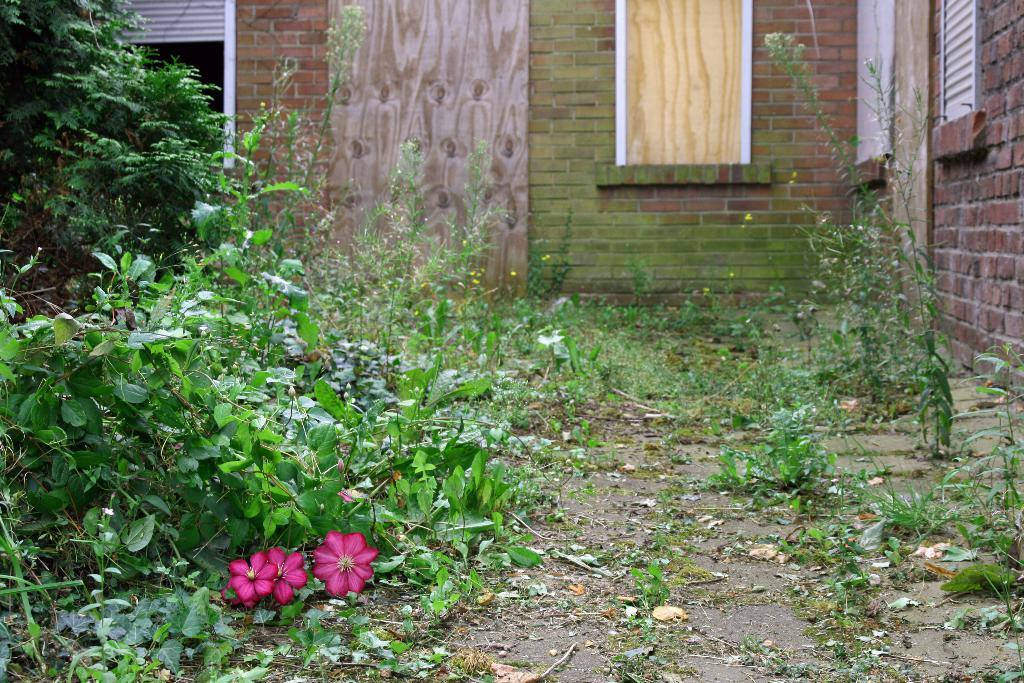What type of plants are present in the image? There are plants with flowers in the image. What color are the flowers on the plants? The flowers are pink in color. What can be seen in the background of the image? There is a brick wall and windows visible in the background of the image. Are there any toys visible in the image? No, there are no toys present in the image. Can you see any fairies flying around the flowers in the image? No, there are no fairies present in the image. 